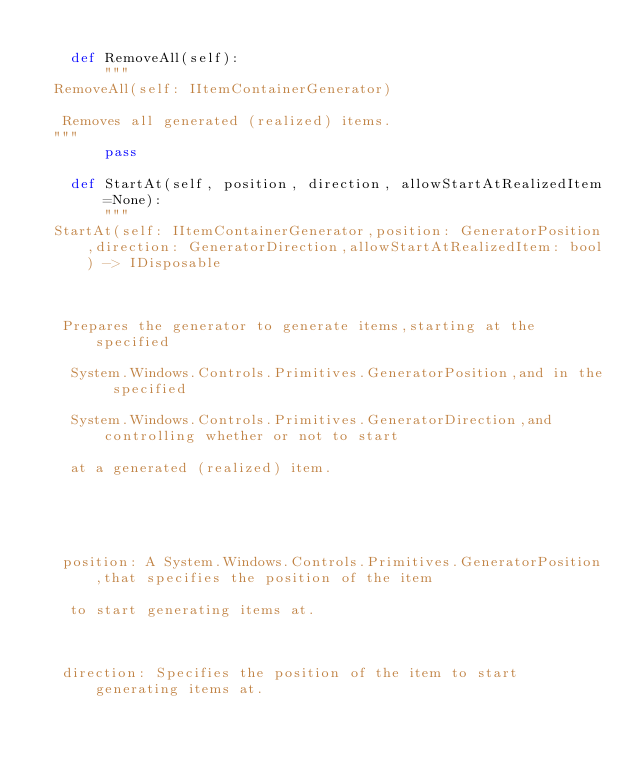Convert code to text. <code><loc_0><loc_0><loc_500><loc_500><_Python_>
    def RemoveAll(self):
        """
  RemoveAll(self: IItemContainerGenerator)

   Removes all generated (realized) items.
  """
        pass

    def StartAt(self, position, direction, allowStartAtRealizedItem=None):
        """
  StartAt(self: IItemContainerGenerator,position: GeneratorPosition,direction: GeneratorDirection,allowStartAtRealizedItem: bool) -> IDisposable

  

   Prepares the generator to generate items,starting at the specified 

    System.Windows.Controls.Primitives.GeneratorPosition,and in the specified 

    System.Windows.Controls.Primitives.GeneratorDirection,and controlling whether or not to start 

    at a generated (realized) item.

  

  

   position: A System.Windows.Controls.Primitives.GeneratorPosition,that specifies the position of the item 

    to start generating items at.

  

   direction: Specifies the position of the item to start generating items at.
</code> 